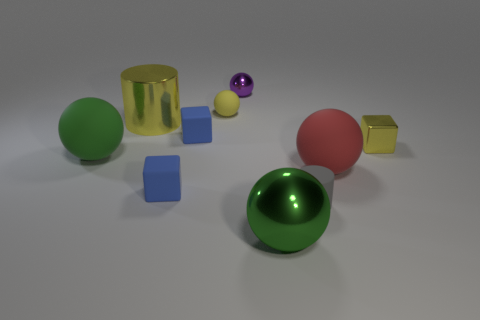Subtract all tiny yellow cubes. How many cubes are left? 2 Subtract all cylinders. How many objects are left? 8 Subtract 2 blocks. How many blocks are left? 1 Subtract all gray balls. How many yellow cylinders are left? 1 Subtract all small matte things. Subtract all tiny matte cylinders. How many objects are left? 5 Add 8 green matte objects. How many green matte objects are left? 9 Add 4 small green cylinders. How many small green cylinders exist? 4 Subtract all yellow balls. How many balls are left? 4 Subtract 1 red spheres. How many objects are left? 9 Subtract all purple cylinders. Subtract all cyan spheres. How many cylinders are left? 2 